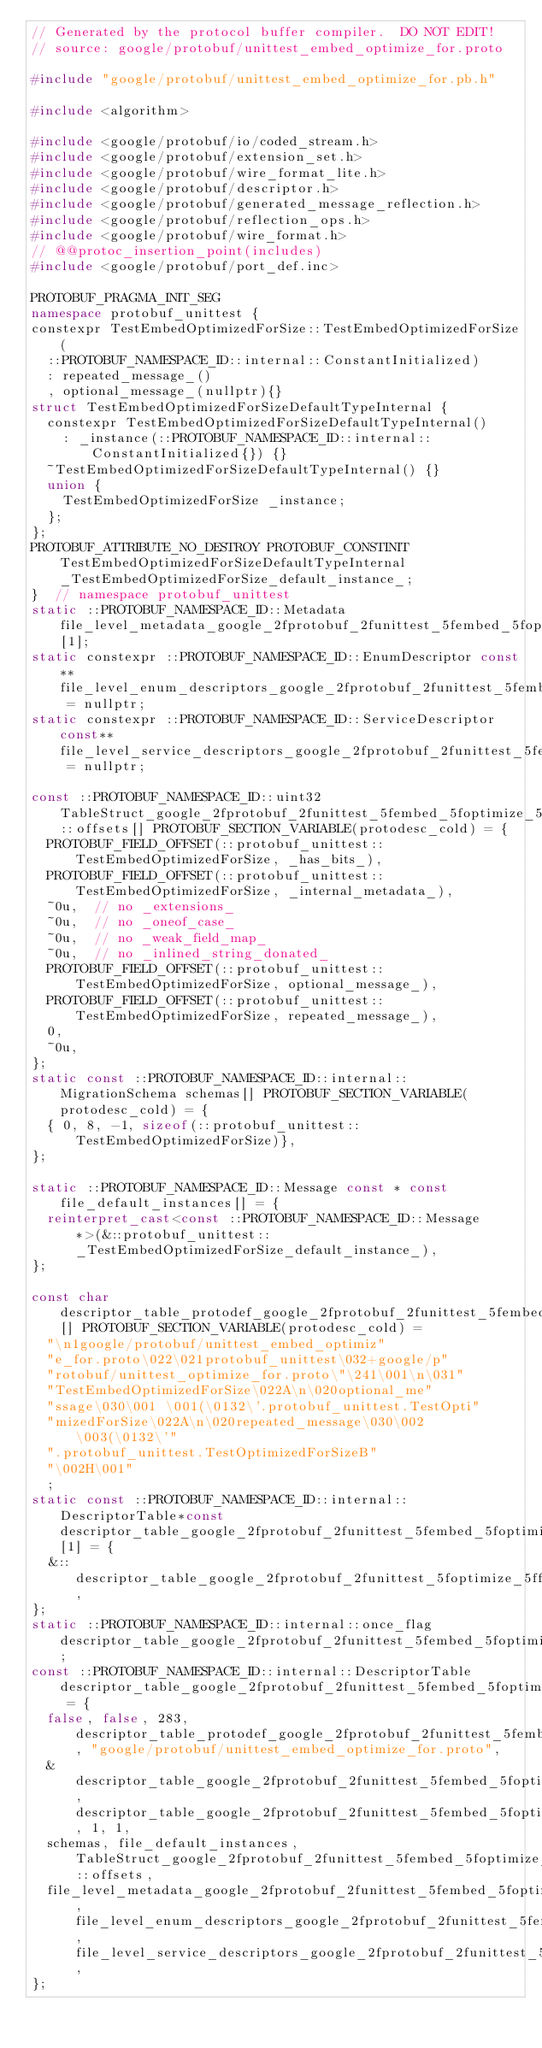Convert code to text. <code><loc_0><loc_0><loc_500><loc_500><_C++_>// Generated by the protocol buffer compiler.  DO NOT EDIT!
// source: google/protobuf/unittest_embed_optimize_for.proto

#include "google/protobuf/unittest_embed_optimize_for.pb.h"

#include <algorithm>

#include <google/protobuf/io/coded_stream.h>
#include <google/protobuf/extension_set.h>
#include <google/protobuf/wire_format_lite.h>
#include <google/protobuf/descriptor.h>
#include <google/protobuf/generated_message_reflection.h>
#include <google/protobuf/reflection_ops.h>
#include <google/protobuf/wire_format.h>
// @@protoc_insertion_point(includes)
#include <google/protobuf/port_def.inc>

PROTOBUF_PRAGMA_INIT_SEG
namespace protobuf_unittest {
constexpr TestEmbedOptimizedForSize::TestEmbedOptimizedForSize(
  ::PROTOBUF_NAMESPACE_ID::internal::ConstantInitialized)
  : repeated_message_()
  , optional_message_(nullptr){}
struct TestEmbedOptimizedForSizeDefaultTypeInternal {
  constexpr TestEmbedOptimizedForSizeDefaultTypeInternal()
    : _instance(::PROTOBUF_NAMESPACE_ID::internal::ConstantInitialized{}) {}
  ~TestEmbedOptimizedForSizeDefaultTypeInternal() {}
  union {
    TestEmbedOptimizedForSize _instance;
  };
};
PROTOBUF_ATTRIBUTE_NO_DESTROY PROTOBUF_CONSTINIT TestEmbedOptimizedForSizeDefaultTypeInternal _TestEmbedOptimizedForSize_default_instance_;
}  // namespace protobuf_unittest
static ::PROTOBUF_NAMESPACE_ID::Metadata file_level_metadata_google_2fprotobuf_2funittest_5fembed_5foptimize_5ffor_2eproto[1];
static constexpr ::PROTOBUF_NAMESPACE_ID::EnumDescriptor const** file_level_enum_descriptors_google_2fprotobuf_2funittest_5fembed_5foptimize_5ffor_2eproto = nullptr;
static constexpr ::PROTOBUF_NAMESPACE_ID::ServiceDescriptor const** file_level_service_descriptors_google_2fprotobuf_2funittest_5fembed_5foptimize_5ffor_2eproto = nullptr;

const ::PROTOBUF_NAMESPACE_ID::uint32 TableStruct_google_2fprotobuf_2funittest_5fembed_5foptimize_5ffor_2eproto::offsets[] PROTOBUF_SECTION_VARIABLE(protodesc_cold) = {
  PROTOBUF_FIELD_OFFSET(::protobuf_unittest::TestEmbedOptimizedForSize, _has_bits_),
  PROTOBUF_FIELD_OFFSET(::protobuf_unittest::TestEmbedOptimizedForSize, _internal_metadata_),
  ~0u,  // no _extensions_
  ~0u,  // no _oneof_case_
  ~0u,  // no _weak_field_map_
  ~0u,  // no _inlined_string_donated_
  PROTOBUF_FIELD_OFFSET(::protobuf_unittest::TestEmbedOptimizedForSize, optional_message_),
  PROTOBUF_FIELD_OFFSET(::protobuf_unittest::TestEmbedOptimizedForSize, repeated_message_),
  0,
  ~0u,
};
static const ::PROTOBUF_NAMESPACE_ID::internal::MigrationSchema schemas[] PROTOBUF_SECTION_VARIABLE(protodesc_cold) = {
  { 0, 8, -1, sizeof(::protobuf_unittest::TestEmbedOptimizedForSize)},
};

static ::PROTOBUF_NAMESPACE_ID::Message const * const file_default_instances[] = {
  reinterpret_cast<const ::PROTOBUF_NAMESPACE_ID::Message*>(&::protobuf_unittest::_TestEmbedOptimizedForSize_default_instance_),
};

const char descriptor_table_protodef_google_2fprotobuf_2funittest_5fembed_5foptimize_5ffor_2eproto[] PROTOBUF_SECTION_VARIABLE(protodesc_cold) =
  "\n1google/protobuf/unittest_embed_optimiz"
  "e_for.proto\022\021protobuf_unittest\032+google/p"
  "rotobuf/unittest_optimize_for.proto\"\241\001\n\031"
  "TestEmbedOptimizedForSize\022A\n\020optional_me"
  "ssage\030\001 \001(\0132\'.protobuf_unittest.TestOpti"
  "mizedForSize\022A\n\020repeated_message\030\002 \003(\0132\'"
  ".protobuf_unittest.TestOptimizedForSizeB"
  "\002H\001"
  ;
static const ::PROTOBUF_NAMESPACE_ID::internal::DescriptorTable*const descriptor_table_google_2fprotobuf_2funittest_5fembed_5foptimize_5ffor_2eproto_deps[1] = {
  &::descriptor_table_google_2fprotobuf_2funittest_5foptimize_5ffor_2eproto,
};
static ::PROTOBUF_NAMESPACE_ID::internal::once_flag descriptor_table_google_2fprotobuf_2funittest_5fembed_5foptimize_5ffor_2eproto_once;
const ::PROTOBUF_NAMESPACE_ID::internal::DescriptorTable descriptor_table_google_2fprotobuf_2funittest_5fembed_5foptimize_5ffor_2eproto = {
  false, false, 283, descriptor_table_protodef_google_2fprotobuf_2funittest_5fembed_5foptimize_5ffor_2eproto, "google/protobuf/unittest_embed_optimize_for.proto", 
  &descriptor_table_google_2fprotobuf_2funittest_5fembed_5foptimize_5ffor_2eproto_once, descriptor_table_google_2fprotobuf_2funittest_5fembed_5foptimize_5ffor_2eproto_deps, 1, 1,
  schemas, file_default_instances, TableStruct_google_2fprotobuf_2funittest_5fembed_5foptimize_5ffor_2eproto::offsets,
  file_level_metadata_google_2fprotobuf_2funittest_5fembed_5foptimize_5ffor_2eproto, file_level_enum_descriptors_google_2fprotobuf_2funittest_5fembed_5foptimize_5ffor_2eproto, file_level_service_descriptors_google_2fprotobuf_2funittest_5fembed_5foptimize_5ffor_2eproto,
};</code> 